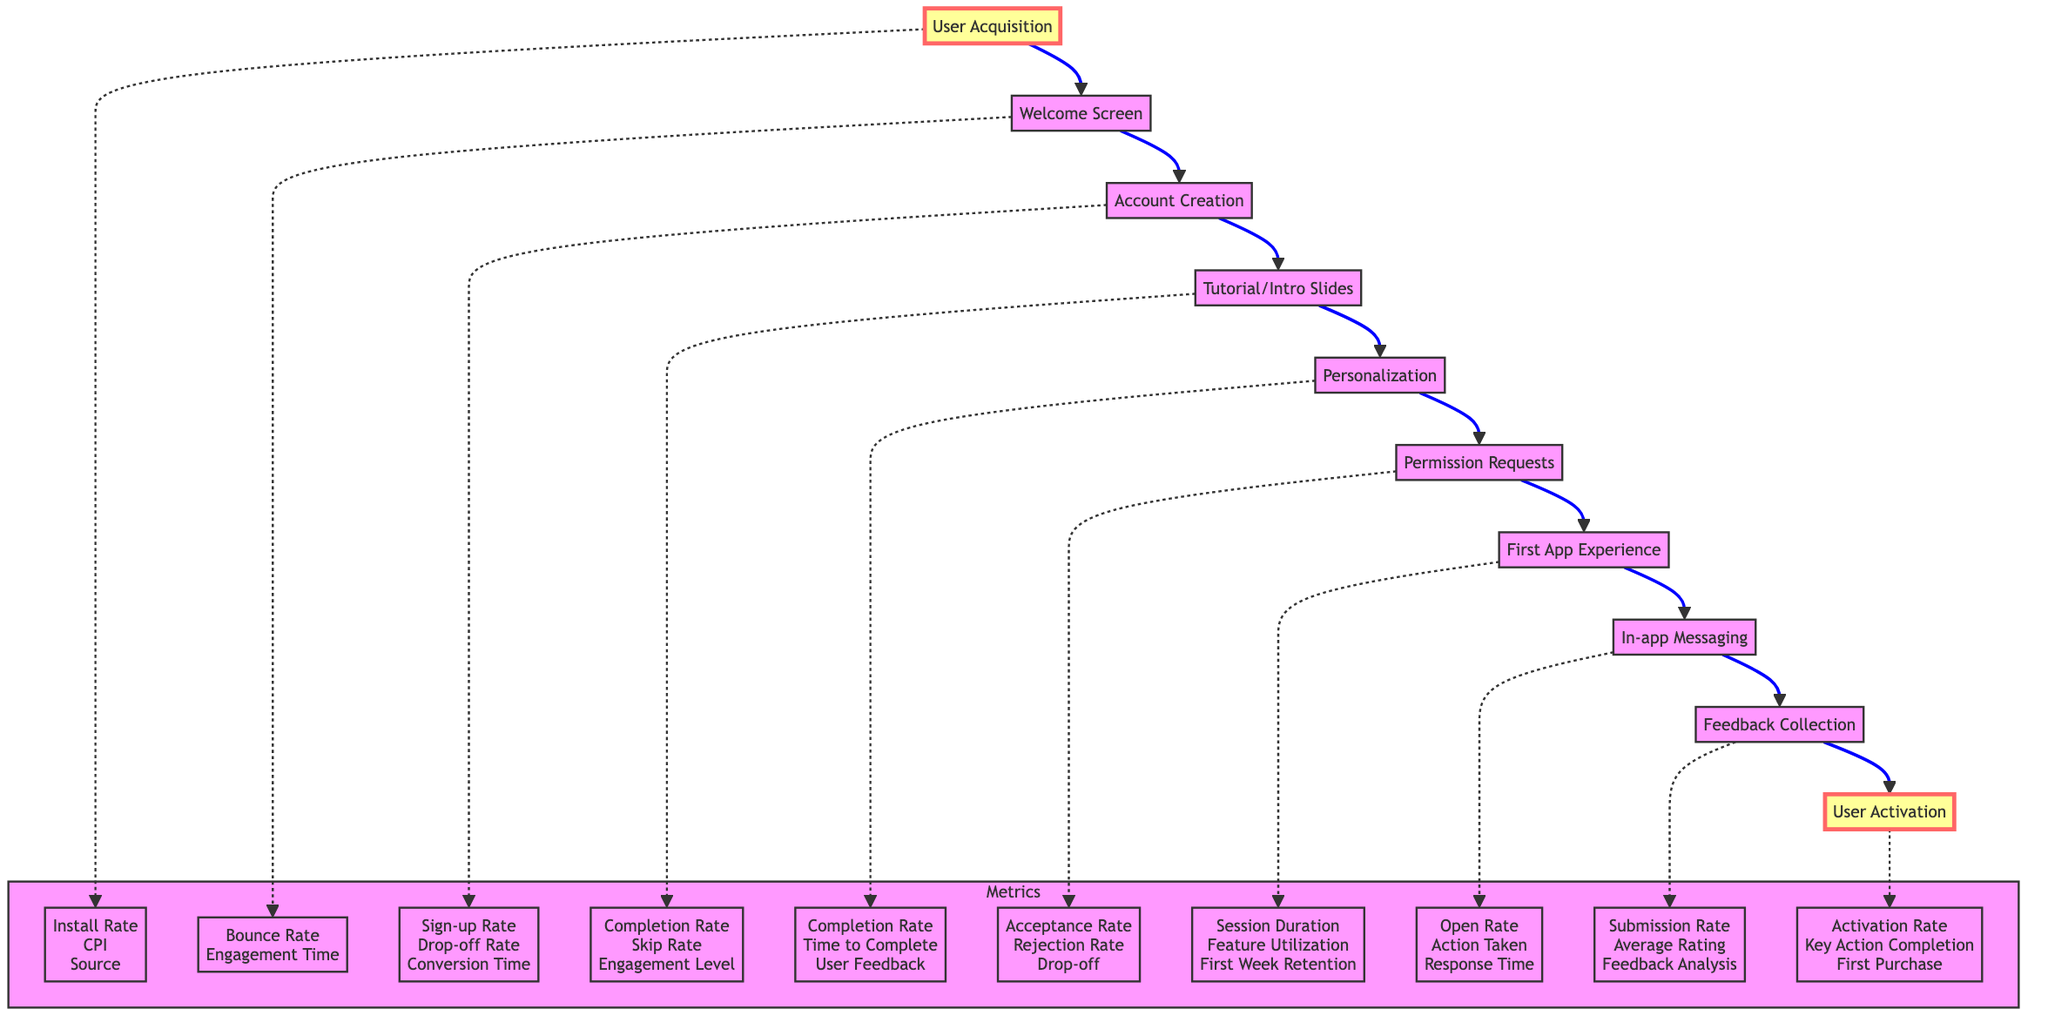What is the first step in the user onboarding process? The first step, as indicated in the diagram, is "User Acquisition." It is the point where new users discover and install the app.
Answer: User Acquisition What metric is associated with the "Welcome Screen"? The diagram shows that the metrics related to the "Welcome Screen" include "Bounce Rate" and "Engagement Time," among others. Here we consider these as principal metrics linked to this node.
Answer: Bounce Rate How many total steps are outlined in the onboarding process? Counting the nodes in the diagram, there are ten distinct steps from "User Acquisition" to "User Activation."
Answer: Ten Which node comes immediately after "Tutorial/Intro Slides"? The diagram indicates that "Personalization" follows directly after "Tutorial/Intro Slides," showing the flow of the onboarding process.
Answer: Personalization What is the purpose of the "Feedback Collection" node? According to the diagram, the "Feedback Collection" stage is designed to ask users for feedback about their onboarding experience, which aims to improve user satisfaction and engagement.
Answer: Asking for feedback What metric is used to evaluate user interaction during the "First App Experience"? The "First App Experience" evaluates user interaction with metrics such as "Session Duration," which records the time spent by users interacting with the app features.
Answer: Session Duration How does the onboarding flow conclude? The flow ends with the "User Activation" node, which ensures that users have started to gain value from the app, signifying the completion of the onboarding process.
Answer: User Activation Which node in the flowchart has multiple metrics related to user acceptance? The "Permission Requests" node features metrics such as "Acceptance Rate," "Rejection Rate," and "Drop-off at Permission Request," demonstrating various aspects of user engagement with permission prompts.
Answer: Permission Requests How do the nodes relate to user acquisition and activation? The flowchart illustrates a clear pathway from "User Acquisition" to "User Activation," encompassing various stages where each links to metrics that help evaluate user engagement and onboarding success.
Answer: From User Acquisition to User Activation 